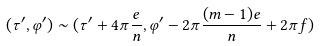<formula> <loc_0><loc_0><loc_500><loc_500>( \tau ^ { \prime } , \varphi ^ { \prime } ) \sim ( \tau ^ { \prime } + 4 \pi \frac { e } { n } , \varphi ^ { \prime } - 2 \pi \frac { ( m - 1 ) e } { n } + 2 \pi f )</formula> 